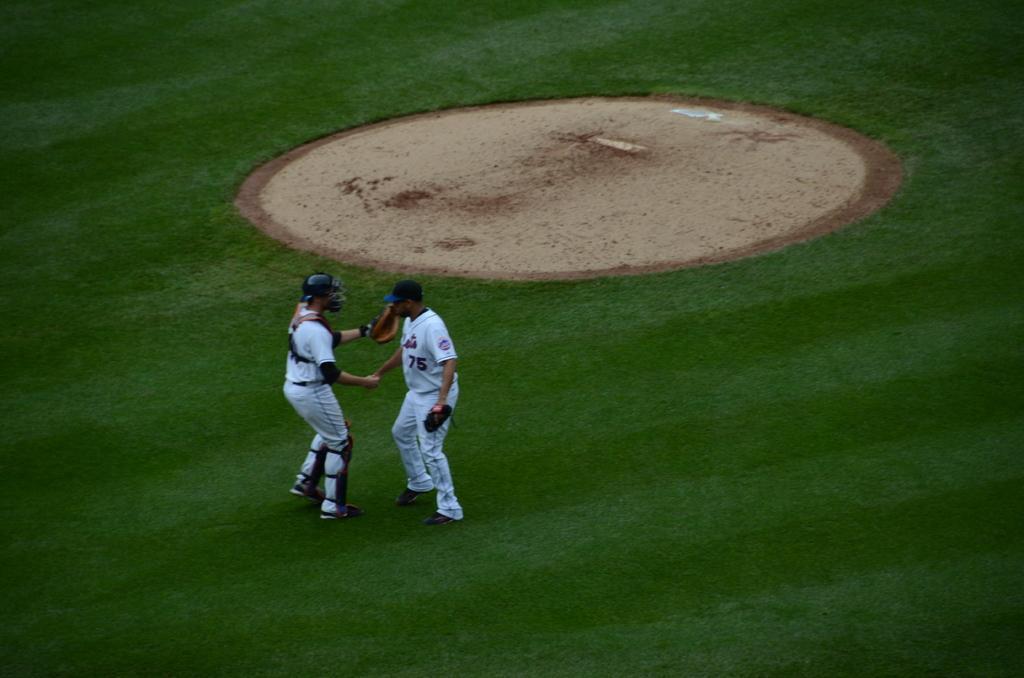Could you give a brief overview of what you see in this image? In the image we can see two men standing, wearing clothes and shoes. This person is wearing a glove and helmet, this is a grass, sand and a cap. 